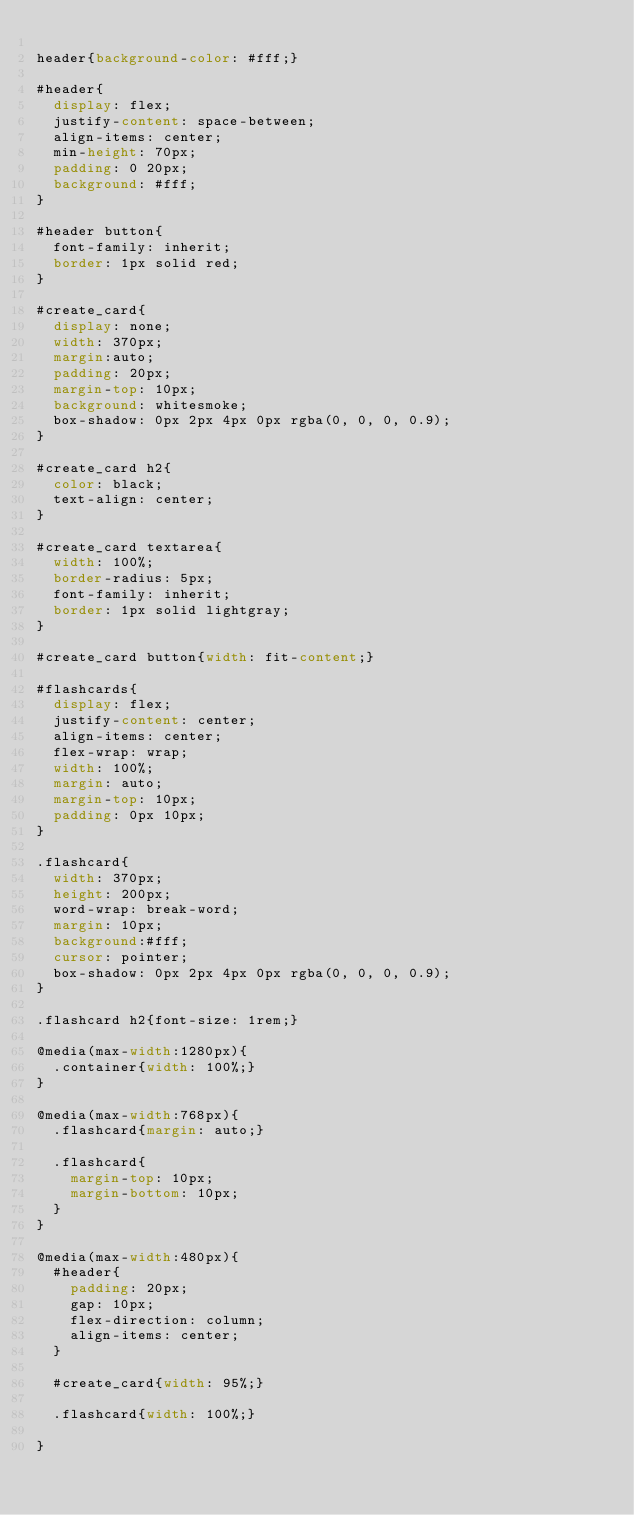<code> <loc_0><loc_0><loc_500><loc_500><_CSS_>
header{background-color: #fff;}

#header{
  display: flex;
  justify-content: space-between;
  align-items: center;
  min-height: 70px;
  padding: 0 20px;
  background: #fff;
}

#header button{
  font-family: inherit;
  border: 1px solid red;
}

#create_card{
  display: none;
  width: 370px;
  margin:auto;
  padding: 20px;
  margin-top: 10px;
  background: whitesmoke;
  box-shadow: 0px 2px 4px 0px rgba(0, 0, 0, 0.9);
}

#create_card h2{
  color: black;
  text-align: center;
}

#create_card textarea{
  width: 100%;
  border-radius: 5px;
  font-family: inherit;
  border: 1px solid lightgray;
}

#create_card button{width: fit-content;}

#flashcards{
  display: flex;
  justify-content: center;
  align-items: center;
  flex-wrap: wrap;
  width: 100%;
  margin: auto;
  margin-top: 10px;
  padding: 0px 10px;
}

.flashcard{
  width: 370px;
  height: 200px;
  word-wrap: break-word;
  margin: 10px; 
  background:#fff;
  cursor: pointer;
  box-shadow: 0px 2px 4px 0px rgba(0, 0, 0, 0.9);
}

.flashcard h2{font-size: 1rem;}

@media(max-width:1280px){
  .container{width: 100%;}
}

@media(max-width:768px){
  .flashcard{margin: auto;}

  .flashcard{
    margin-top: 10px;
    margin-bottom: 10px;
  }
}

@media(max-width:480px){
  #header{
    padding: 20px;
    gap: 10px;
    flex-direction: column;
    align-items: center;
  }

  #create_card{width: 95%;}

  .flashcard{width: 100%;}

}
</code> 